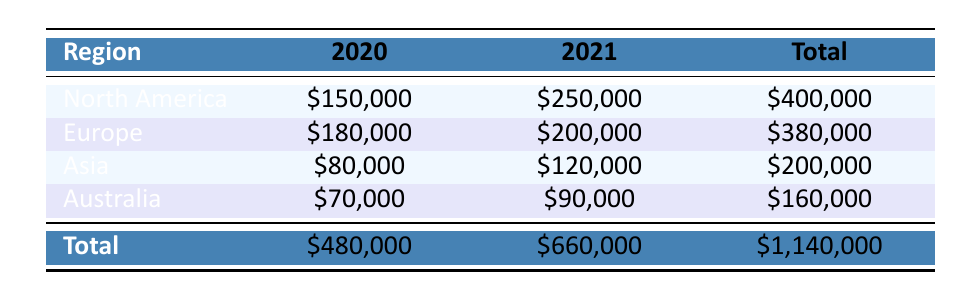What were the total sales for North America in 2020? In the table, North America's sales for 2020 are listed as \$150,000.
Answer: \$150,000 Which region sold more historical fiction books in 2021? North America sold \$250,000, Europe sold \$200,000, Asia sold \$120,000, and Australia sold \$90,000. Therefore, North America had the highest sales in 2021.
Answer: North America What is the total sales amount for all regions combined in 2020? By summing the sales for each region in 2020: \$150,000 (North America) + \$180,000 (Europe) + \$80,000 (Asia) + \$70,000 (Australia) gives a total of \$480,000.
Answer: \$480,000 Did Asia's sales in 2021 exceed those in 2020? Asia's sales were \$120,000 in 2021 and \$80,000 in 2020. Since \$120,000 is more than \$80,000, it indicates that 2021 sales did exceed those of 2020.
Answer: Yes What was the difference in sales between 2020 and 2021 for Europe? The sales for Europe were \$180,000 in 2020 and \$200,000 in 2021. The difference is calculated by subtracting \$180,000 from \$200,000, resulting in an increase of \$20,000.
Answer: \$20,000 What is the average sales amount for Australia? The total sales for Australia in 2020 and 2021 are \$70,000 and \$90,000, respectively. Summing these gives \$160,000. Dividing by the number of years, which is 2, gives an average of \$80,000.
Answer: \$80,000 Which region had the highest total sales across both years? Total sales for each region: North America: \$400,000, Europe: \$380,000, Asia: \$200,000, Australia: \$160,000. The highest total is North America with \$400,000.
Answer: North America Was the total sales for all regions in 2021 greater than that of 2020? In 2021, total sales were \$660,000 and in 2020 they were \$480,000. Since \$660,000 is greater than \$480,000, the total for 2021 was indeed higher.
Answer: Yes Which book had the highest sales in North America? North America’s sales show "The Nightingale" with \$250,000 and "The Book Thief" with \$150,000. The higher value of \$250,000 indicates that "The Nightingale" had the highest sales.
Answer: The Nightingale 